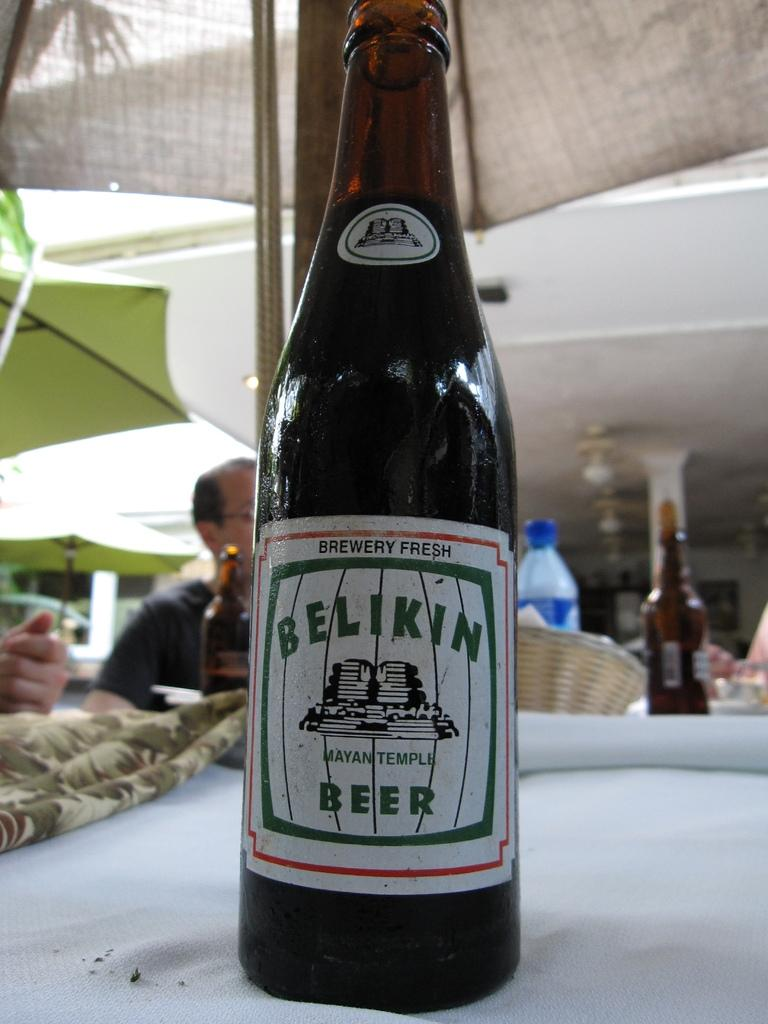<image>
Present a compact description of the photo's key features. A bottle of Belikin Beer is labeled as being brewery fresh. 